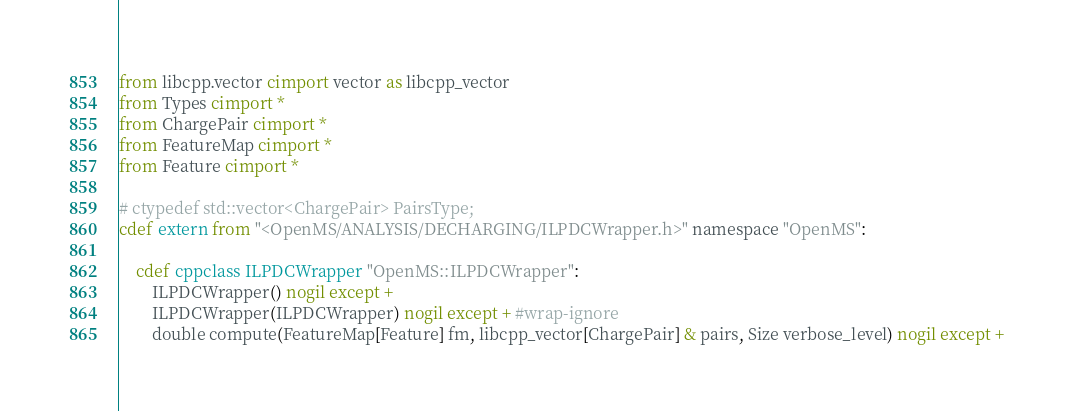<code> <loc_0><loc_0><loc_500><loc_500><_Cython_>from libcpp.vector cimport vector as libcpp_vector
from Types cimport *
from ChargePair cimport *
from FeatureMap cimport *
from Feature cimport *

# ctypedef std::vector<ChargePair> PairsType;
cdef extern from "<OpenMS/ANALYSIS/DECHARGING/ILPDCWrapper.h>" namespace "OpenMS":
    
    cdef cppclass ILPDCWrapper "OpenMS::ILPDCWrapper":
        ILPDCWrapper() nogil except +
        ILPDCWrapper(ILPDCWrapper) nogil except + #wrap-ignore
        double compute(FeatureMap[Feature] fm, libcpp_vector[ChargePair] & pairs, Size verbose_level) nogil except +

</code> 